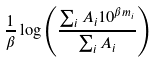Convert formula to latex. <formula><loc_0><loc_0><loc_500><loc_500>\frac { 1 } { \beta } \log \left ( \frac { \sum _ { i } { A _ { i } 1 0 ^ { \beta m _ { i } } } } { \sum _ { i } A _ { i } } \right )</formula> 